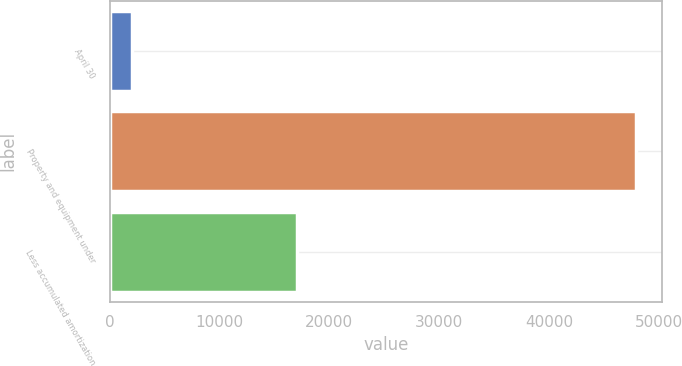Convert chart. <chart><loc_0><loc_0><loc_500><loc_500><bar_chart><fcel>April 30<fcel>Property and equipment under<fcel>Less accumulated amortization<nl><fcel>2008<fcel>47913<fcel>17090<nl></chart> 